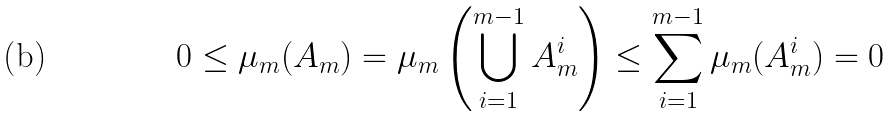Convert formula to latex. <formula><loc_0><loc_0><loc_500><loc_500>0 \leq \mu _ { m } ( A _ { m } ) = \mu _ { m } \left ( \bigcup _ { i = 1 } ^ { m - 1 } A _ { m } ^ { i } \right ) \leq \sum _ { i = 1 } ^ { m - 1 } \mu _ { m } ( A _ { m } ^ { i } ) = 0</formula> 